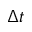Convert formula to latex. <formula><loc_0><loc_0><loc_500><loc_500>\Delta t</formula> 